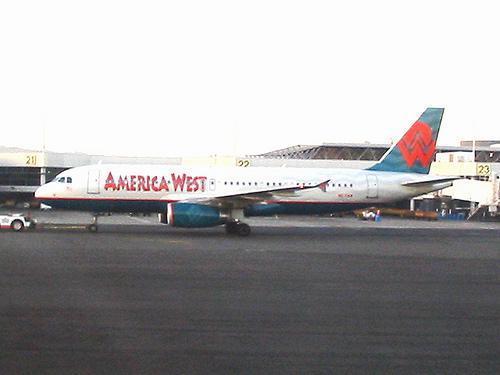How many gate numbers are shown in the picture?
Give a very brief answer. 3. How many letters are on the airplane's tail?
Give a very brief answer. 2. 